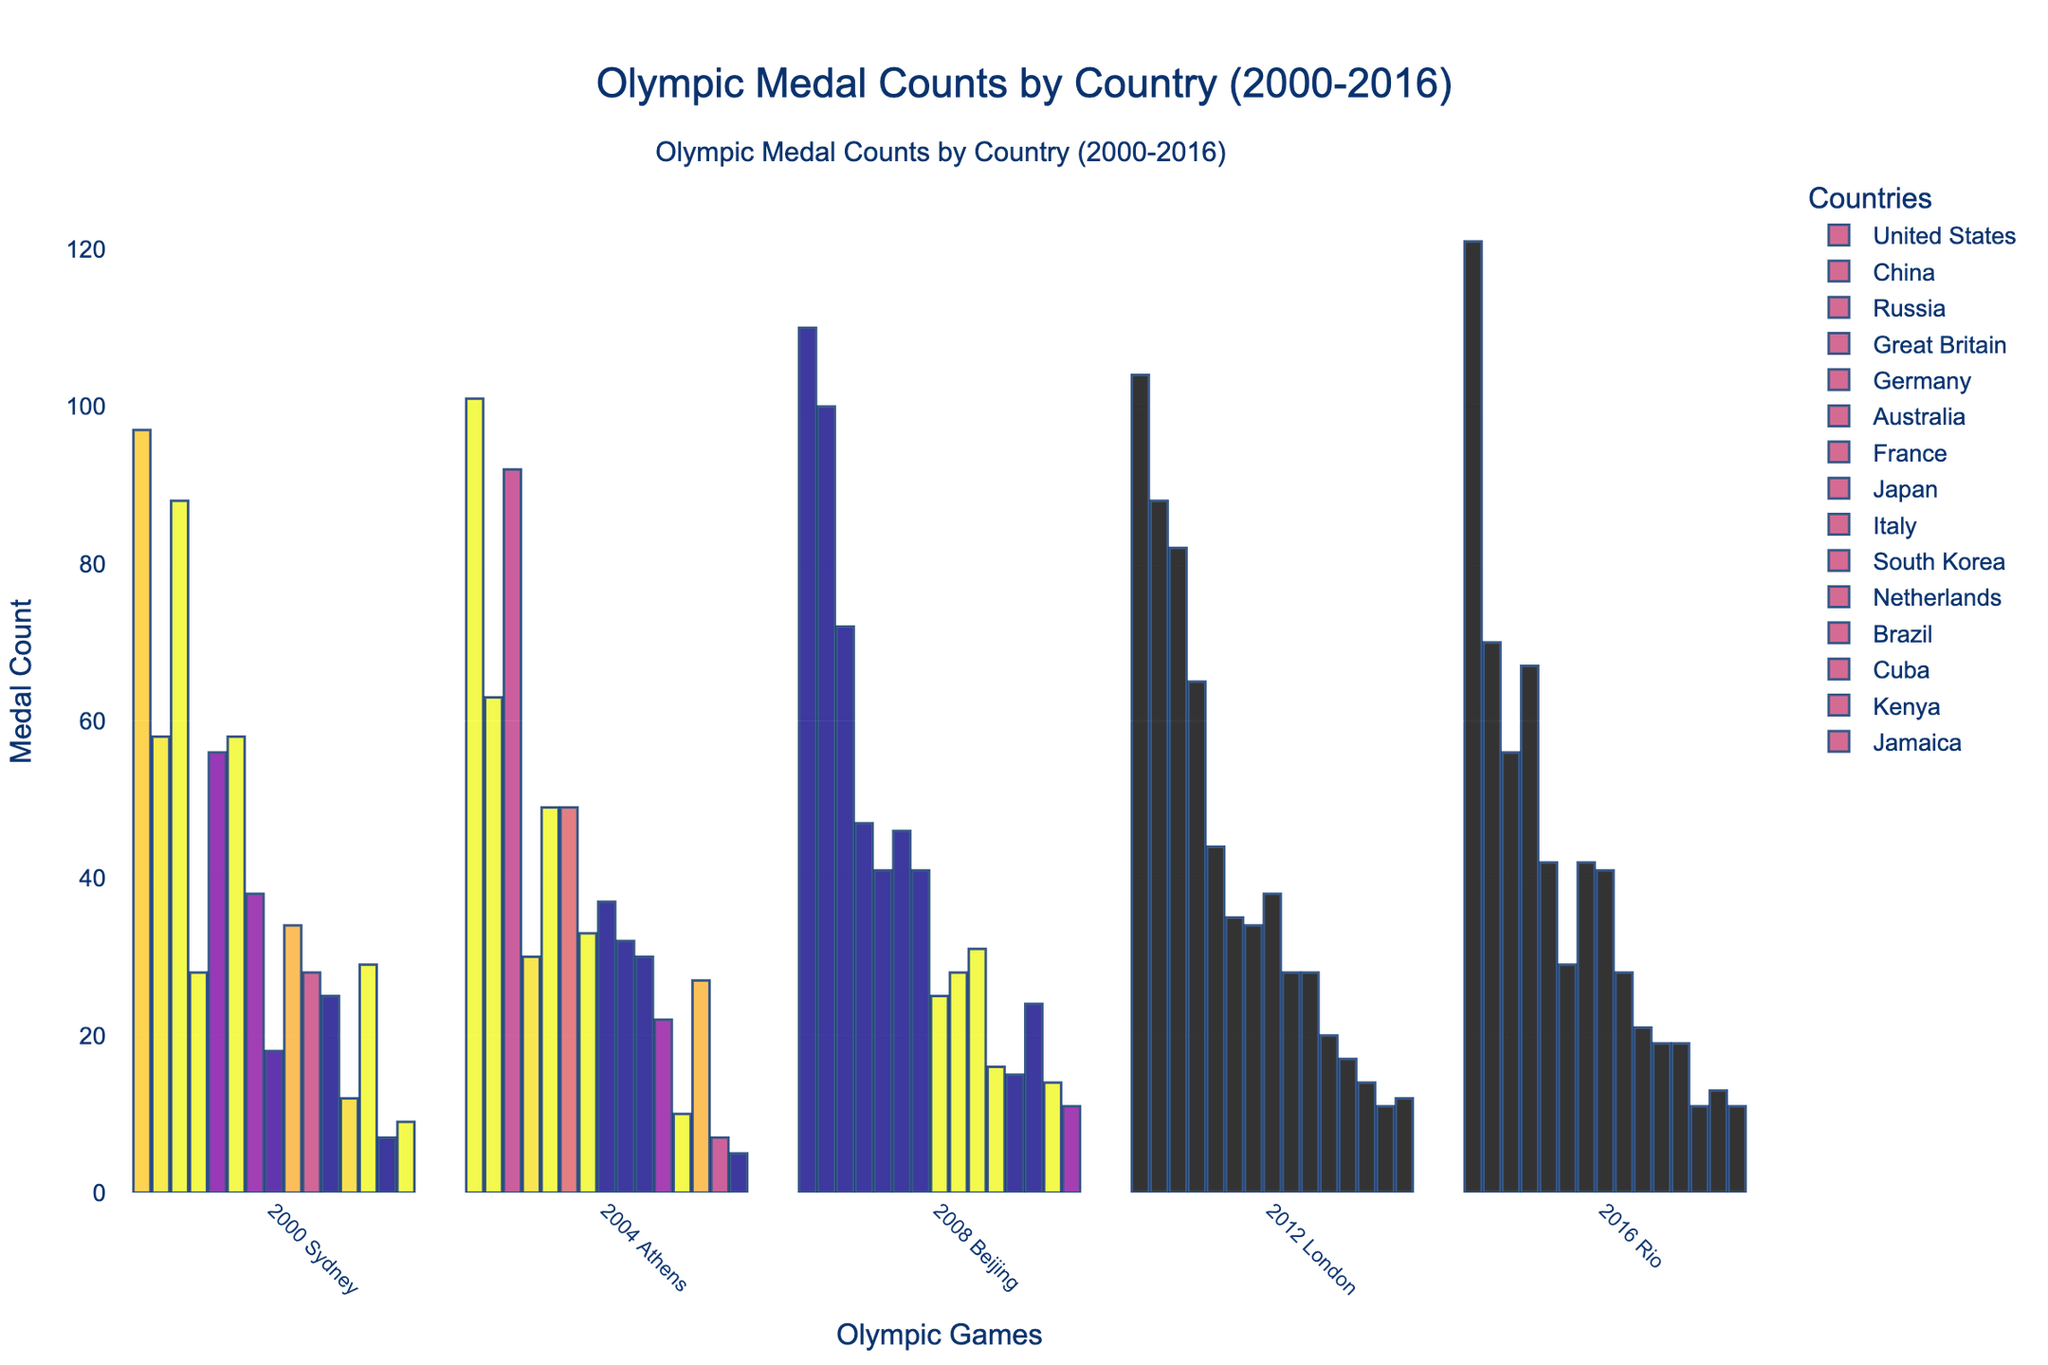Which country won the most medals overall in the 2016 Rio Olympics? By looking at the quantity of the medals in the 2016 column, we see that the United States has the highest bar with 121 medals, making them the country with the most medals.
Answer: United States Which country experienced the largest increase in medal count from the 2004 Athens Olympics to the 2008 Beijing Olympics? To determine the largest increase, subtract the 2004 count from the 2008 count for each country. China increased by 100 - 63 = 37 medals, which is the largest increase.
Answer: China Between Great Britain and Germany, which country had a higher average medal count over the five Summer Games? Calculate the average medal count of both countries over the five events (Great Britain: (28+30+47+65+67)/5 = 47.4, Germany: (56+49+41+44+42)/5 = 46.4). Great Britain's average is higher.
Answer: Great Britain Which country had a decrease in medal count in consecutive Olympics from the highest peak among any of the years data is shown? Notice the trends of declines from the peaks for each country, China peaked at 100 in 2008 and then decreased to 88 in 2012 and 70 in 2016. China had the most significant consecutive decrease.
Answer: China What was the total number of medals won by the United States and China combined in the 2008 Beijing Olympics? Sum the counts for the United States and China from the 2008 column (110 + 100 = 210).
Answer: 210 How did Russia's medal count in the 2016 Rio Olympics compare to their count in the 2000 Sydney Olympics? Compare the counts from the two years (Russia: 56 in 2016, 88 in 2000). Russia's count in 2016 was 32 medals fewer than in 2000.
Answer: 32 fewer Which two countries had the closest medal counts in the 2016 Rio Olympics? By visually inspecting the bars, Australia and the Netherlands had similar heights in 2016 with 29 and 19 respectively. The closest two, however, are Brazil (19) and Netherlands (19).
Answer: Brazil and Netherlands Considering all the data, which country had the most consistent medal count over the five Summer Games? Consistency can be gauged by the smallest variation. Italy's medal counts were steady (34, 32, 28, 28, 28), showing minimal fluctuation.
Answer: Italy What was the difference in the number of medals won by Japan between the 2000 Sydney Olympics and the 2012 London Olympics? Subtract Japan's count in 2000 from their count in 2012 (38 - 18 = 20).
Answer: 20 Which country performed better in the Rio Olympics compared to their performance in the Sydney Olympics, both in terms of absolute numbers and improvement percentage? Compare medal counts in 2000 and 2016 for each country. Great Britain improved from 28 in 2000 to 67 in 2016. The percentage improvement is ((67-28)/28)*100 = 139.29%. Great Britain showed both significant absolute and percentage improvement.
Answer: Great Britain 